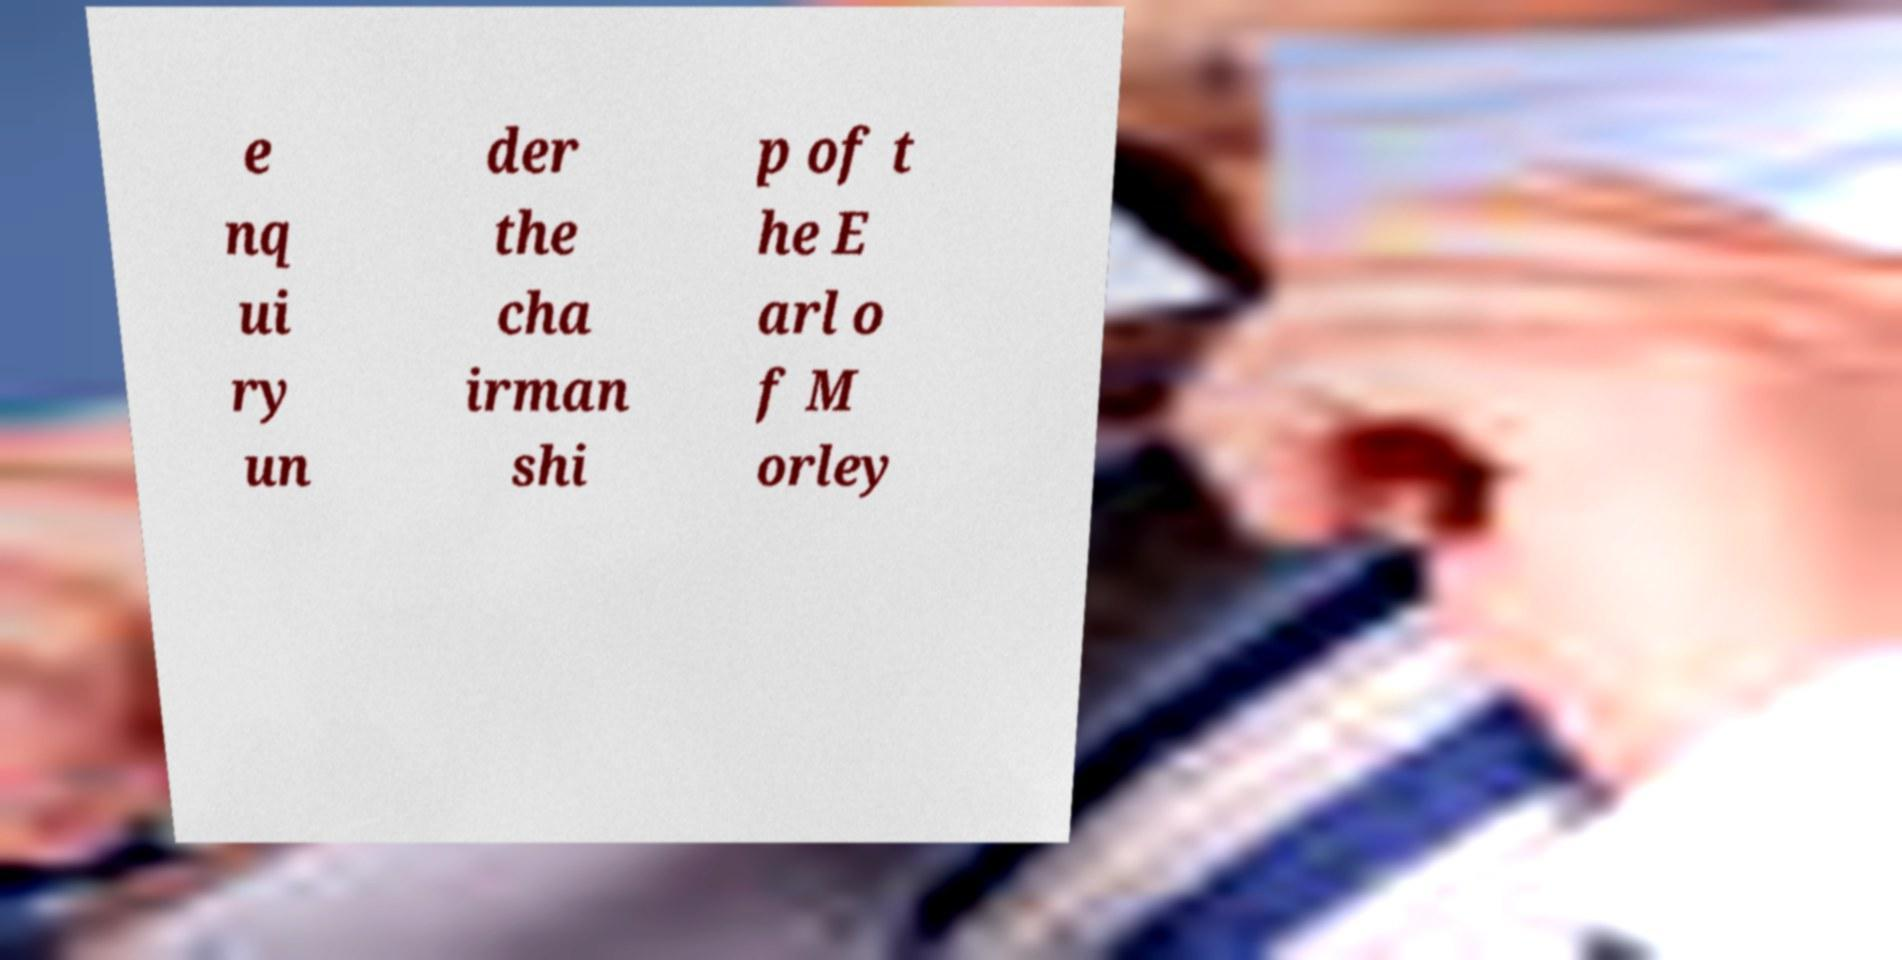Please identify and transcribe the text found in this image. e nq ui ry un der the cha irman shi p of t he E arl o f M orley 